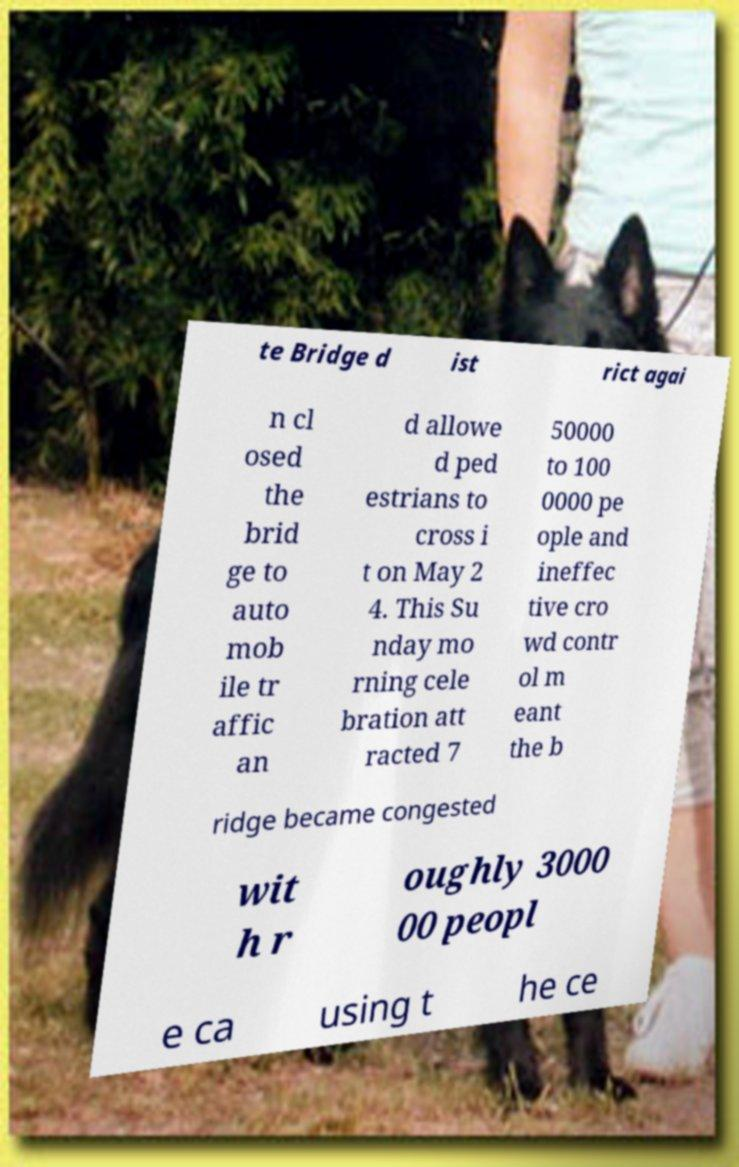Please identify and transcribe the text found in this image. te Bridge d ist rict agai n cl osed the brid ge to auto mob ile tr affic an d allowe d ped estrians to cross i t on May 2 4. This Su nday mo rning cele bration att racted 7 50000 to 100 0000 pe ople and ineffec tive cro wd contr ol m eant the b ridge became congested wit h r oughly 3000 00 peopl e ca using t he ce 